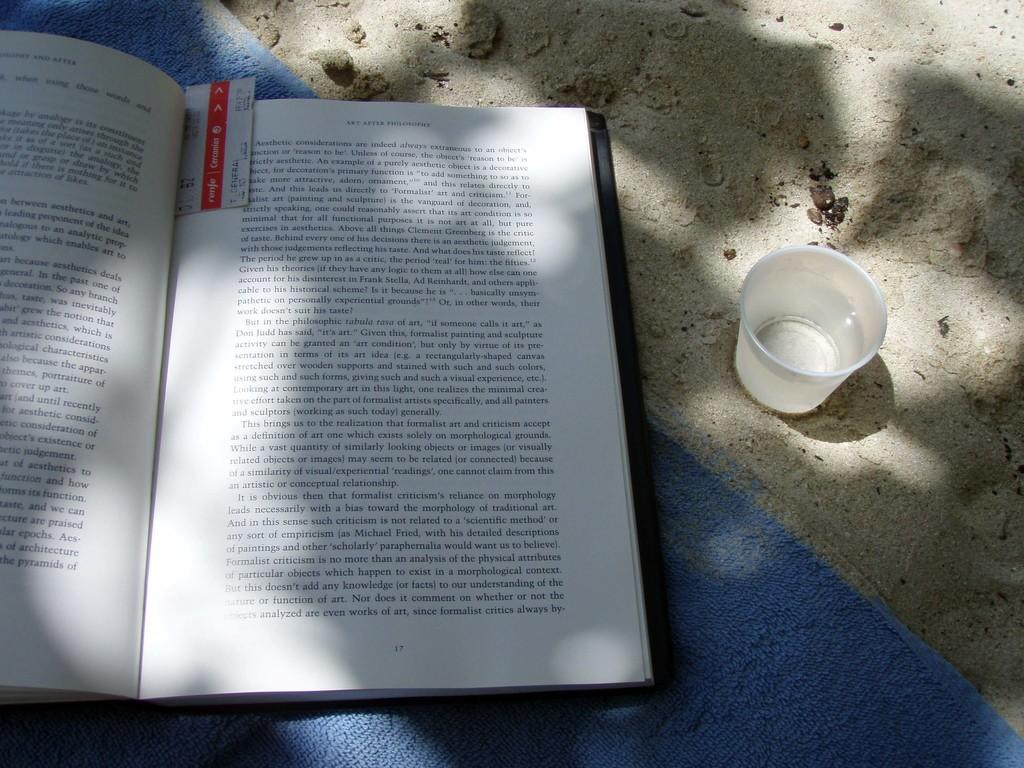<image>
Give a short and clear explanation of the subsequent image. A book, Art After Philosophy, lays open on blue towel on the sand. 